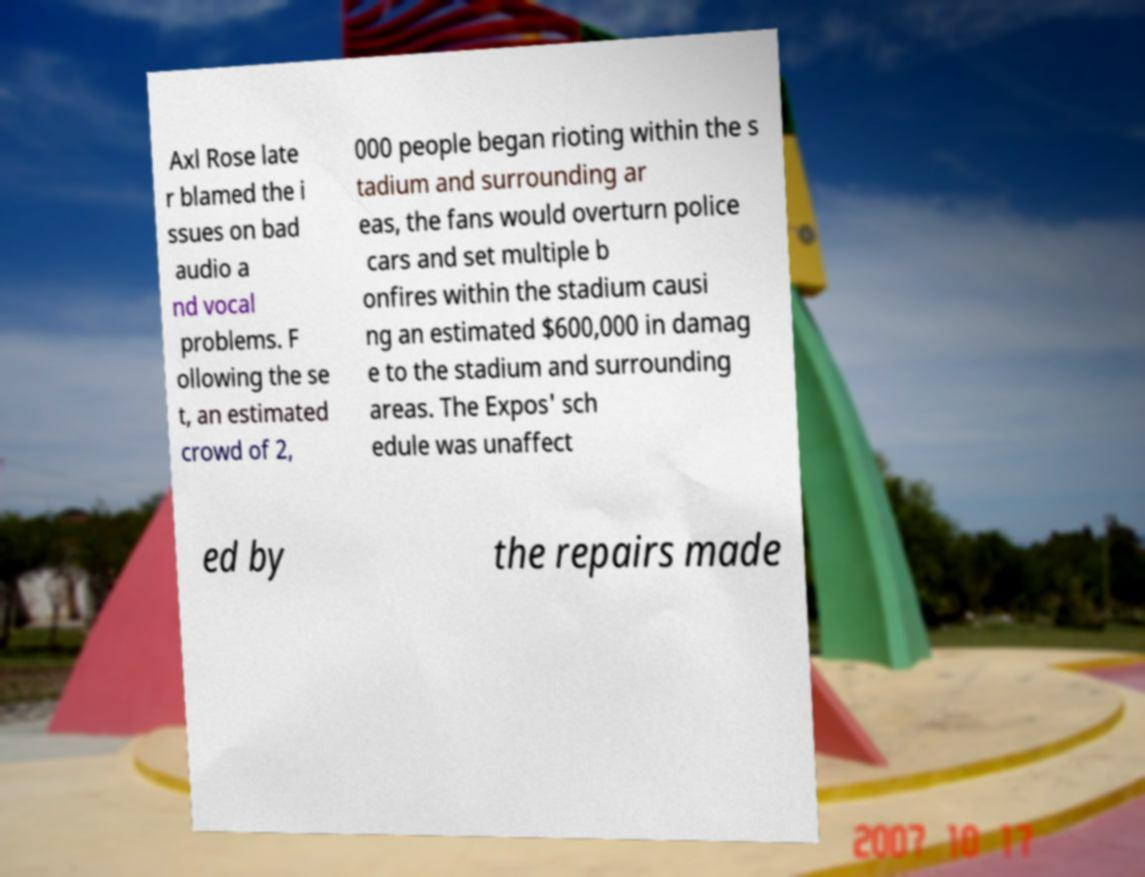For documentation purposes, I need the text within this image transcribed. Could you provide that? Axl Rose late r blamed the i ssues on bad audio a nd vocal problems. F ollowing the se t, an estimated crowd of 2, 000 people began rioting within the s tadium and surrounding ar eas, the fans would overturn police cars and set multiple b onfires within the stadium causi ng an estimated $600,000 in damag e to the stadium and surrounding areas. The Expos' sch edule was unaffect ed by the repairs made 